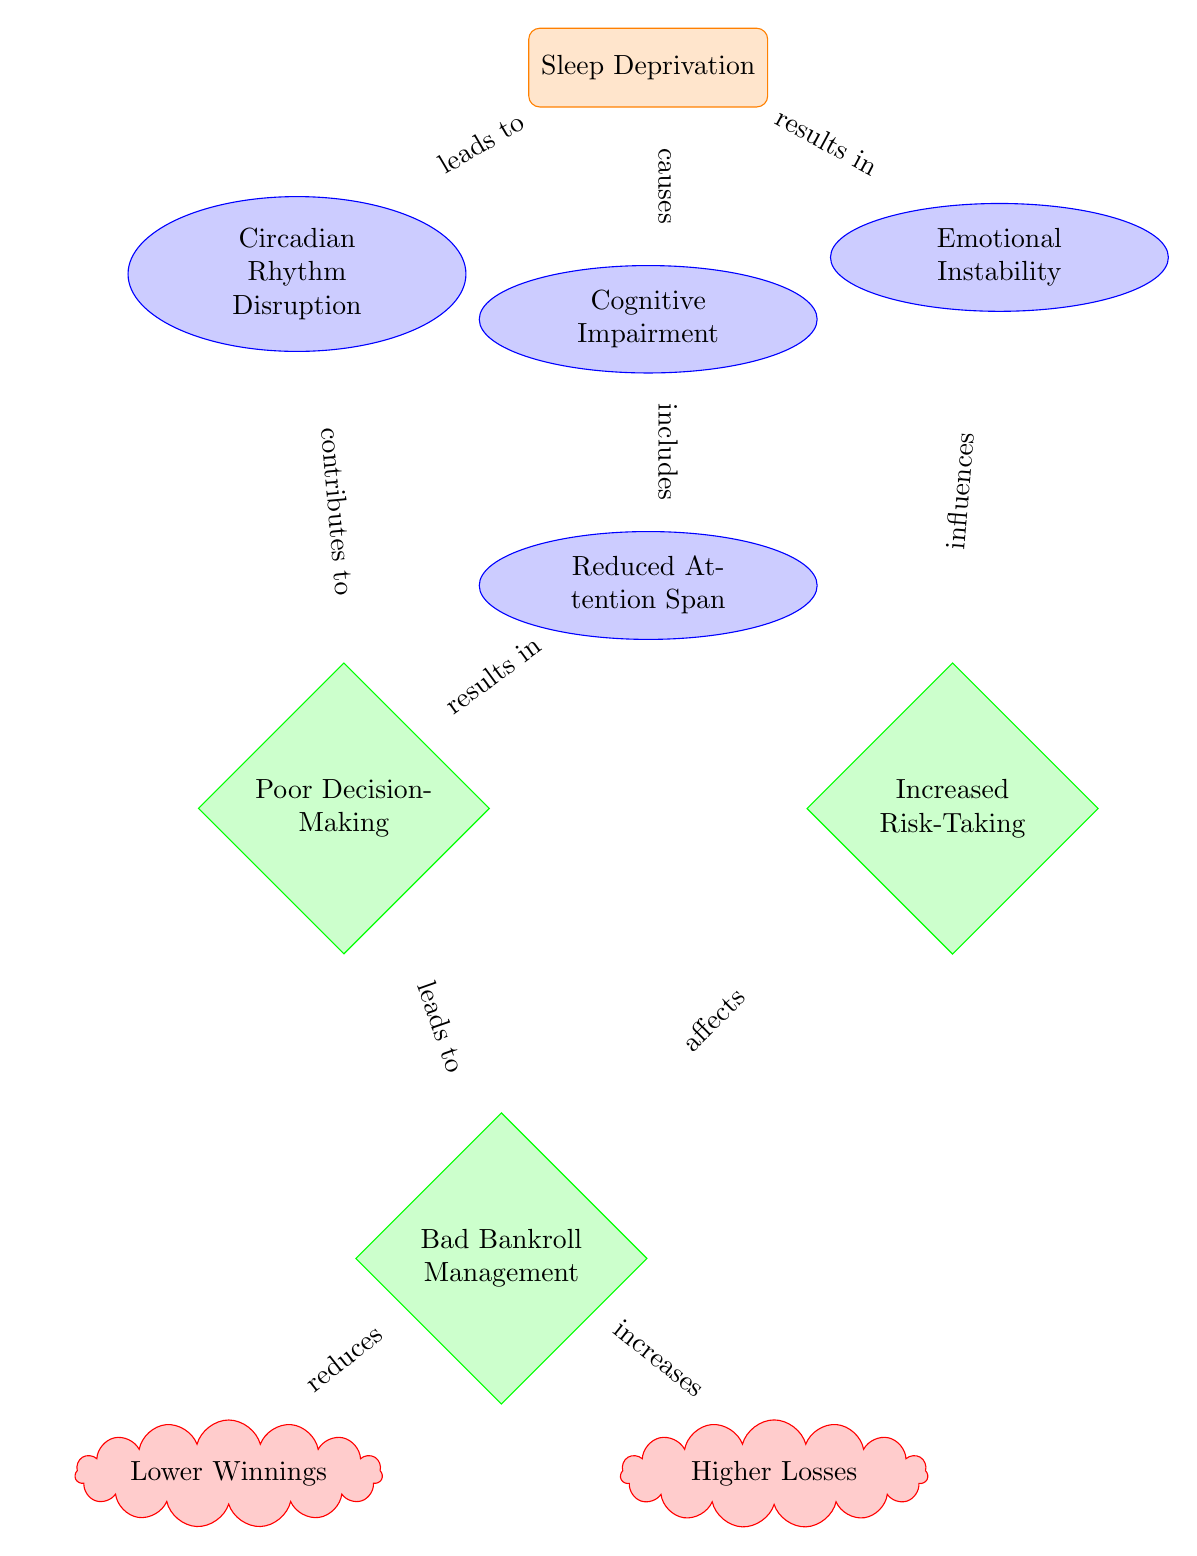What is the main factor depicted in the diagram? The diagram highlights "Sleep Deprivation" as the main factor that initiates the flow of effects.
Answer: Sleep Deprivation How many outcomes are shown in the diagram? The diagram contains three outcomes represented by diamond shapes. They are "Poor Decision-Making," "Increased Risk-Taking," and "Bad Bankroll Management."
Answer: 3 Which effect is directly influenced by "Circadian Rhythm Disruption"? According to the diagram, "Circadian Rhythm Disruption" contributes directly to "Poor Decision-Making."
Answer: Poor Decision-Making What does "Poor Decision-Making" lead to? The diagram shows that "Poor Decision-Making" leads to "Bad Bankroll Management."
Answer: Bad Bankroll Management How does "Increased Risk-Taking" affect "Bad Bankroll Management"? "Increased Risk-Taking" directly affects "Bad Bankroll Management" in the flow of the diagram.
Answer: Affects What is the relationship between "Cognitive Impairment" and "Reduced Attention Span"? "Cognitive Impairment" includes "Reduced Attention Span" as a specific aspect or result of cognitive issues.
Answer: Includes How do "Bad Bankroll Management" and "Increased Risk-Taking" impact overall outcomes? Both "Bad Bankroll Management" leads to "Lower Winnings" and "Higher Losses," indicating that they negatively influence the financial outcomes for the player.
Answer: Lower Winnings and Higher Losses What type of diagram elements are "Circadian Rhythm Disruption," "Cognitive Impairment," and "Emotional Instability"? These elements are categorized as effects, represented by ellipse shapes in the diagram.
Answer: Effects Which factor is indicated to be the root cause of the other effects and outcomes? The diagram identifies "Sleep Deprivation" as the root cause influencing all other aspects illustrated.
Answer: Sleep Deprivation 